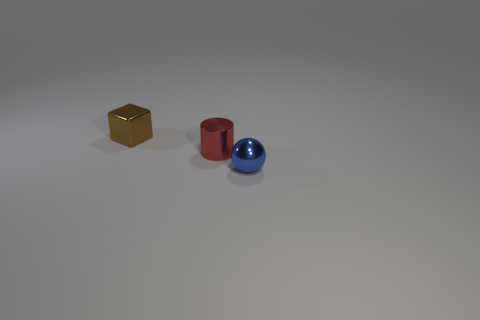Add 3 small spheres. How many objects exist? 6 Subtract all balls. How many objects are left? 2 Add 2 brown things. How many brown things are left? 3 Add 2 small cyan shiny balls. How many small cyan shiny balls exist? 2 Subtract 1 red cylinders. How many objects are left? 2 Subtract all blue metal spheres. Subtract all brown metallic objects. How many objects are left? 1 